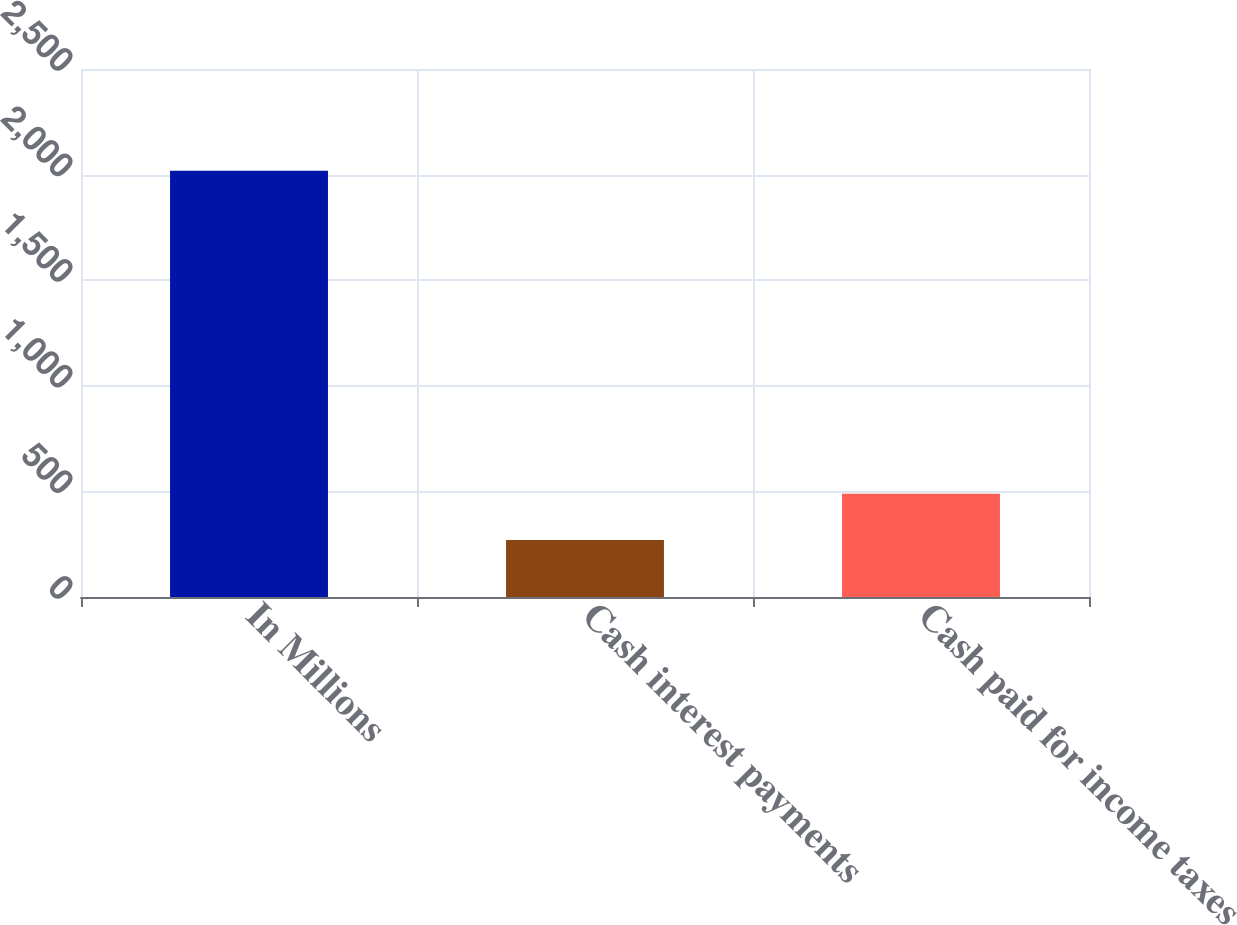<chart> <loc_0><loc_0><loc_500><loc_500><bar_chart><fcel>In Millions<fcel>Cash interest payments<fcel>Cash paid for income taxes<nl><fcel>2018<fcel>269.5<fcel>489.4<nl></chart> 